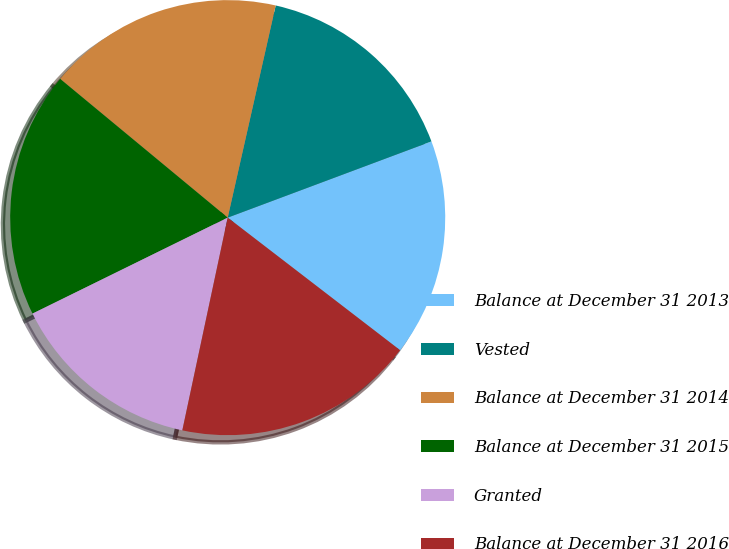<chart> <loc_0><loc_0><loc_500><loc_500><pie_chart><fcel>Balance at December 31 2013<fcel>Vested<fcel>Balance at December 31 2014<fcel>Balance at December 31 2015<fcel>Granted<fcel>Balance at December 31 2016<nl><fcel>16.13%<fcel>15.76%<fcel>17.53%<fcel>18.28%<fcel>14.38%<fcel>17.91%<nl></chart> 